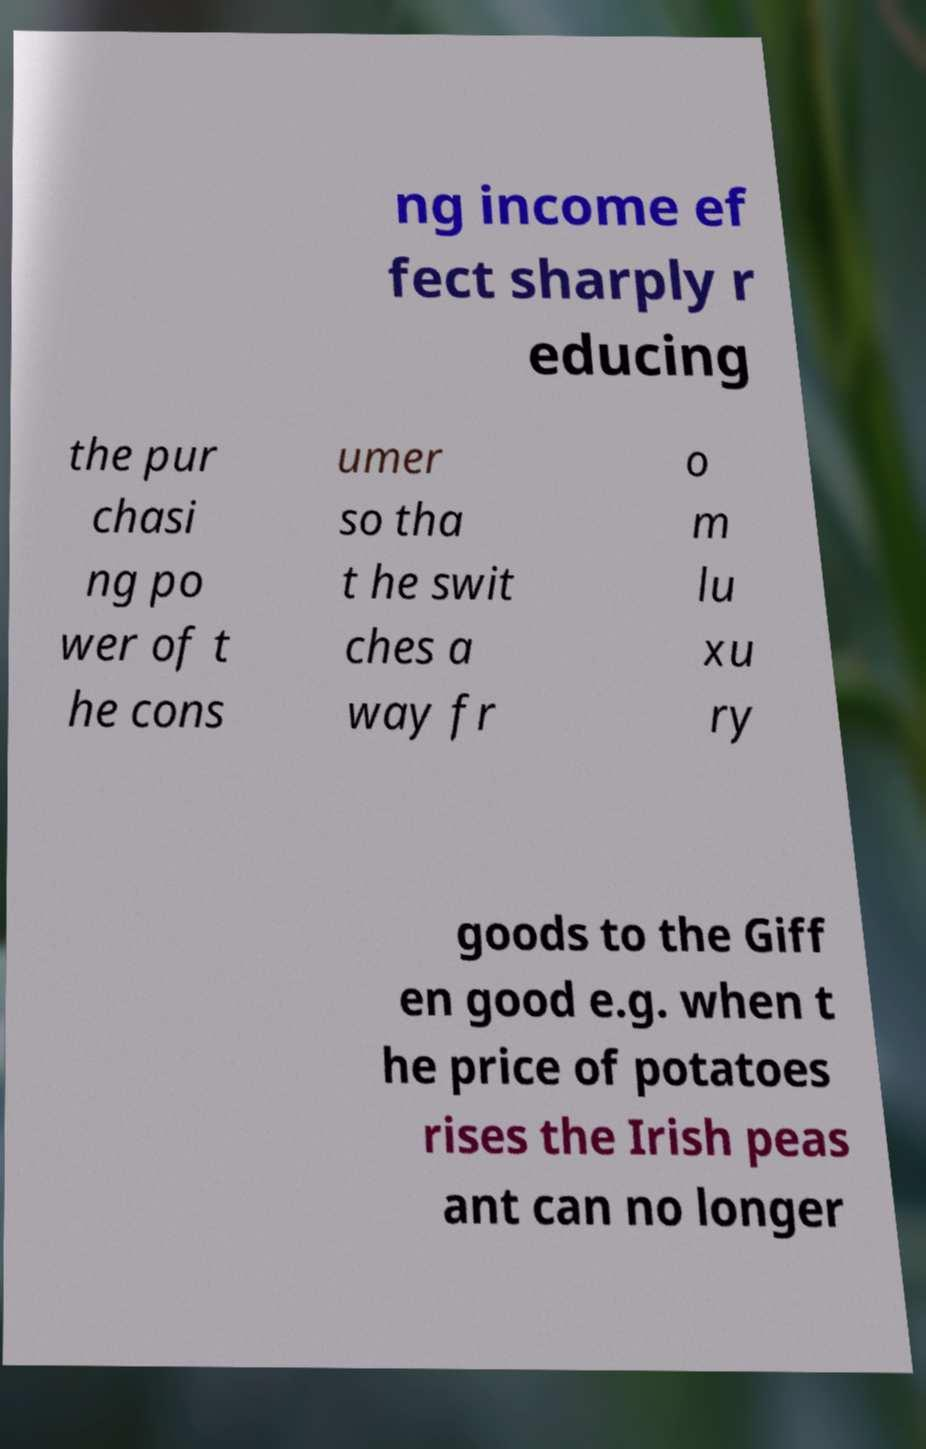Could you assist in decoding the text presented in this image and type it out clearly? ng income ef fect sharply r educing the pur chasi ng po wer of t he cons umer so tha t he swit ches a way fr o m lu xu ry goods to the Giff en good e.g. when t he price of potatoes rises the Irish peas ant can no longer 